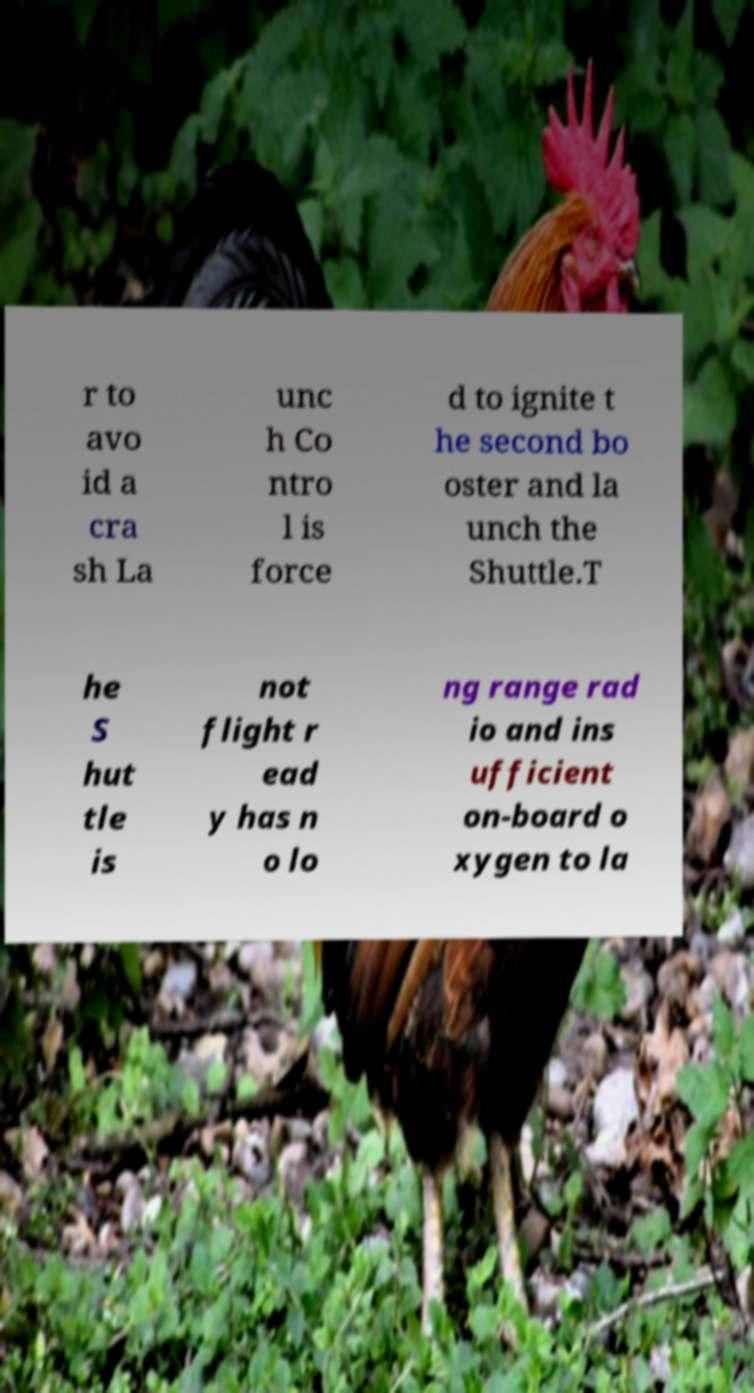Could you assist in decoding the text presented in this image and type it out clearly? r to avo id a cra sh La unc h Co ntro l is force d to ignite t he second bo oster and la unch the Shuttle.T he S hut tle is not flight r ead y has n o lo ng range rad io and ins ufficient on-board o xygen to la 